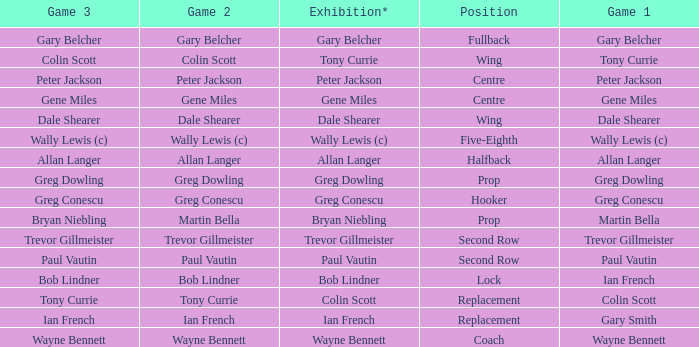Wjat game 3 has ian french as a game of 2? Ian French. 